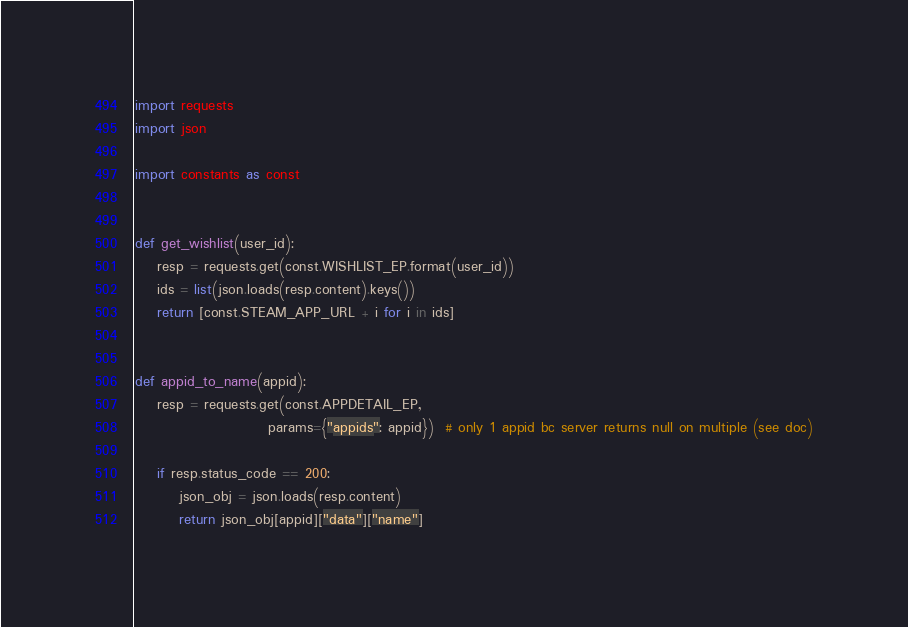<code> <loc_0><loc_0><loc_500><loc_500><_Python_>import requests
import json

import constants as const


def get_wishlist(user_id):
    resp = requests.get(const.WISHLIST_EP.format(user_id))
    ids = list(json.loads(resp.content).keys())
    return [const.STEAM_APP_URL + i for i in ids]


def appid_to_name(appid):
    resp = requests.get(const.APPDETAIL_EP,
                        params={"appids": appid})  # only 1 appid bc server returns null on multiple (see doc)

    if resp.status_code == 200:
        json_obj = json.loads(resp.content)
        return json_obj[appid]["data"]["name"]
</code> 